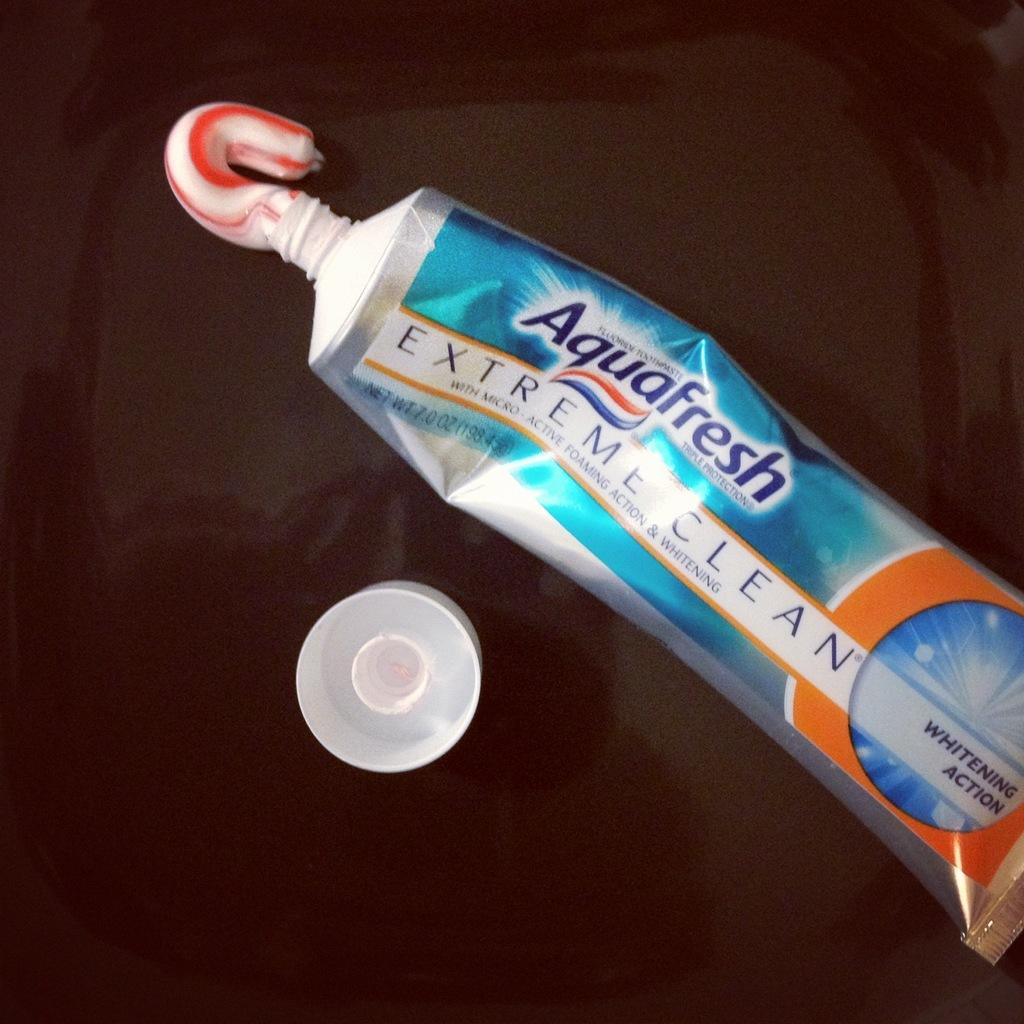Provide a one-sentence caption for the provided image. A tube of Aquafresh extreme clean toothpaste with the cap off. 